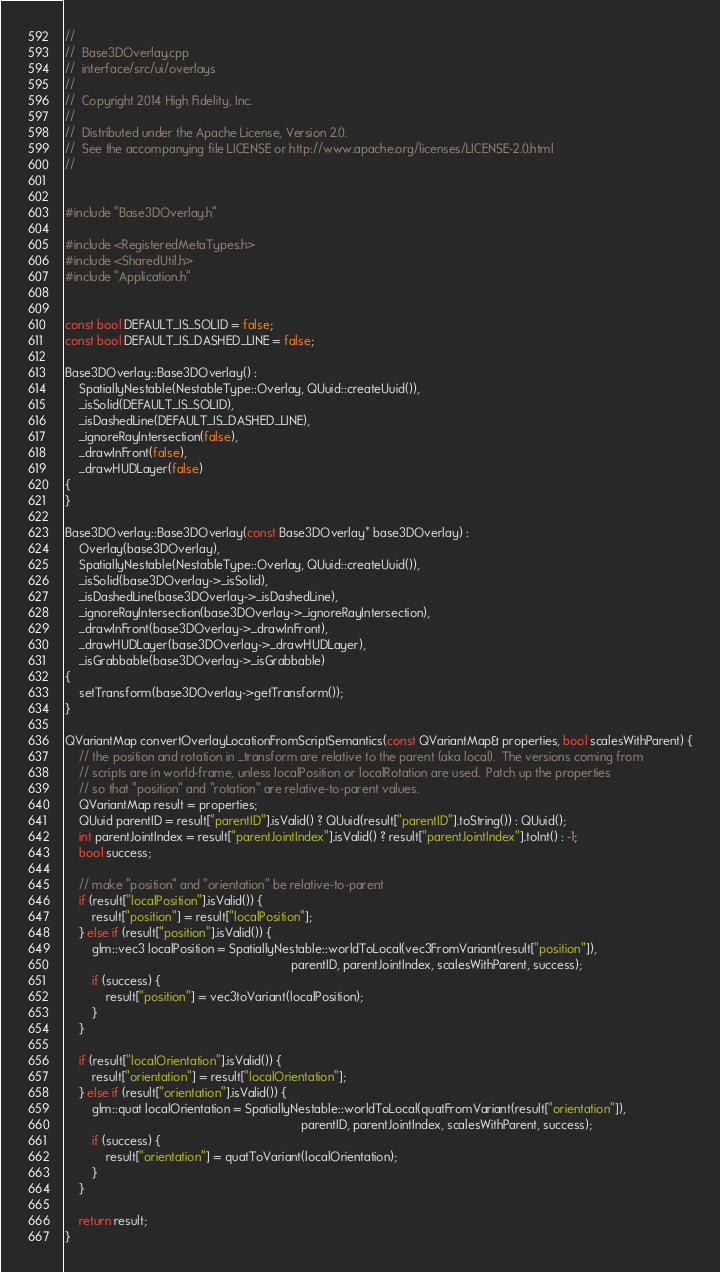Convert code to text. <code><loc_0><loc_0><loc_500><loc_500><_C++_>//
//  Base3DOverlay.cpp
//  interface/src/ui/overlays
//
//  Copyright 2014 High Fidelity, Inc.
//
//  Distributed under the Apache License, Version 2.0.
//  See the accompanying file LICENSE or http://www.apache.org/licenses/LICENSE-2.0.html
//


#include "Base3DOverlay.h"

#include <RegisteredMetaTypes.h>
#include <SharedUtil.h>
#include "Application.h"


const bool DEFAULT_IS_SOLID = false;
const bool DEFAULT_IS_DASHED_LINE = false;

Base3DOverlay::Base3DOverlay() :
    SpatiallyNestable(NestableType::Overlay, QUuid::createUuid()),
    _isSolid(DEFAULT_IS_SOLID),
    _isDashedLine(DEFAULT_IS_DASHED_LINE),
    _ignoreRayIntersection(false),
    _drawInFront(false),
    _drawHUDLayer(false)
{
}

Base3DOverlay::Base3DOverlay(const Base3DOverlay* base3DOverlay) :
    Overlay(base3DOverlay),
    SpatiallyNestable(NestableType::Overlay, QUuid::createUuid()),
    _isSolid(base3DOverlay->_isSolid),
    _isDashedLine(base3DOverlay->_isDashedLine),
    _ignoreRayIntersection(base3DOverlay->_ignoreRayIntersection),
    _drawInFront(base3DOverlay->_drawInFront),
    _drawHUDLayer(base3DOverlay->_drawHUDLayer),
    _isGrabbable(base3DOverlay->_isGrabbable)
{
    setTransform(base3DOverlay->getTransform());
}

QVariantMap convertOverlayLocationFromScriptSemantics(const QVariantMap& properties, bool scalesWithParent) {
    // the position and rotation in _transform are relative to the parent (aka local).  The versions coming from
    // scripts are in world-frame, unless localPosition or localRotation are used.  Patch up the properties
    // so that "position" and "rotation" are relative-to-parent values.
    QVariantMap result = properties;
    QUuid parentID = result["parentID"].isValid() ? QUuid(result["parentID"].toString()) : QUuid();
    int parentJointIndex = result["parentJointIndex"].isValid() ? result["parentJointIndex"].toInt() : -1;
    bool success;

    // make "position" and "orientation" be relative-to-parent
    if (result["localPosition"].isValid()) {
        result["position"] = result["localPosition"];
    } else if (result["position"].isValid()) {
        glm::vec3 localPosition = SpatiallyNestable::worldToLocal(vec3FromVariant(result["position"]),
                                                                  parentID, parentJointIndex, scalesWithParent, success);
        if (success) {
            result["position"] = vec3toVariant(localPosition);
        }
    }

    if (result["localOrientation"].isValid()) {
        result["orientation"] = result["localOrientation"];
    } else if (result["orientation"].isValid()) {
        glm::quat localOrientation = SpatiallyNestable::worldToLocal(quatFromVariant(result["orientation"]),
                                                                     parentID, parentJointIndex, scalesWithParent, success);
        if (success) {
            result["orientation"] = quatToVariant(localOrientation);
        }
    }

    return result;
}
</code> 